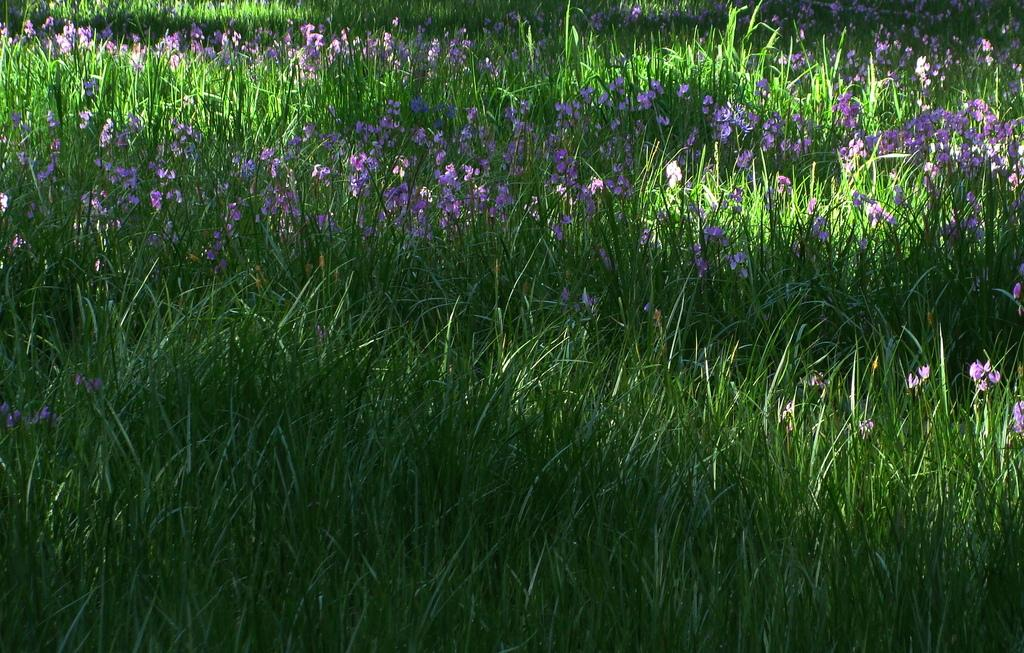What type of vegetation can be seen in the image? There is grass in the image. What other natural elements can be seen in the image? There are flowers in the image. What type of agreement is being signed in the image? There is no agreement or signing activity present in the image; it features grass and flowers. What type of spark can be seen coming from the flowers in the image? There is no spark present in the image; it features grass and flowers in a natural setting. 